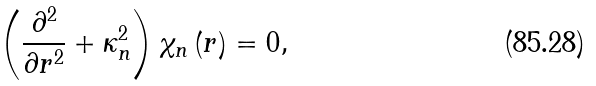<formula> <loc_0><loc_0><loc_500><loc_500>\left ( \frac { \partial ^ { 2 } } { \partial { r } ^ { 2 } } + \kappa _ { n } ^ { 2 } \right ) \chi _ { n } \left ( { r } \right ) = 0 ,</formula> 